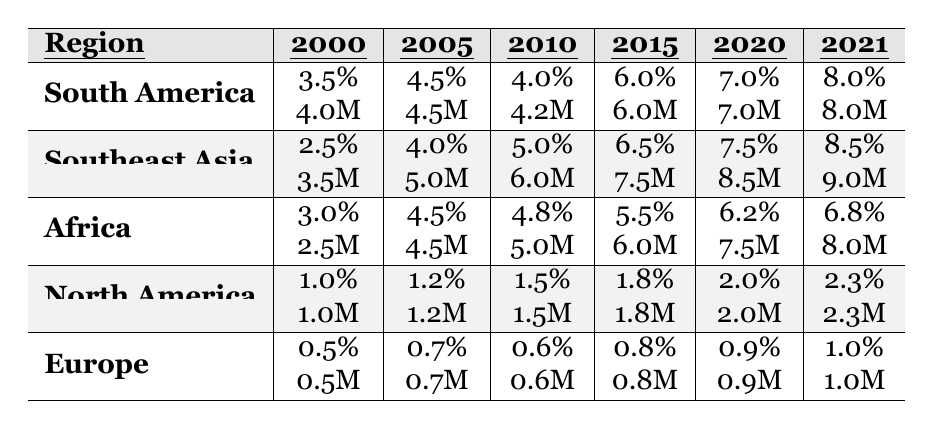What was the deforestation rate in South America in 2010? Looking at the table under the South America row for the year 2010, the deforestation rate is listed as 4.0%.
Answer: 4.0% Which region had the highest deforestation rate in 2021? In the table, reviewing the 2021 column for each region shows that South America had the highest rate at 8.0%.
Answer: South America What is the total deforested area in Southeast Asia from 2000 to 2021? Adding the deforested areas for Southeast Asia from 2000 (3.5M), 2005 (5.0M), 2010 (6.0M), 2015 (7.5M), 2020 (8.5M), and 2021 (9.0M) gives a total of 39.5M hectares.
Answer: 39.5M Has the deforestation rate in Europe ever exceeded 1%? The table shows the deforestation rates for Europe at no point has it exceeded 1%, indicating a 'no' to this question.
Answer: No What was the increase in deforestation rates from 2000 to 2021 for Africa? The deforestation rate for Africa in 2000 is 3.0% and in 2021 is 6.8%. The difference is 6.8% - 3.0% = 3.8%.
Answer: 3.8% Which region showed the most significant increase in deforestation rates between 2015 and 2021? Comparing the rates between 2015 (6.0% for South America, 6.5% for Southeast Asia, 5.5% for Africa, 1.8% for North America, and 0.8% for Europe) reveals that South America increased by 2.0 percentage points (from 6.0% to 8.0%). Southeast Asia also increased by 2.0 percentage points. Africa increased by 1.3 percentage points, North America by 0.5 percentage points, and Europe by 0.2 percentage points. Therefore, South America and Southeast Asia showed the most significant increase.
Answer: South America and Southeast Asia In terms of area deforested in 2020, which region deforested the most area and what was that area? The table indicates that among the regions in 2020, South America deforested 7.0M hectares, which is the highest compared to others.
Answer: South America, 7.0M What is the average deforestation rate for North America across the years 2000 to 2021? The rates for North America are 1.0%, 1.2%, 1.5%, 1.8%, 2.0%, and 2.3%. The average is calculated as (1.0 + 1.2 + 1.5 + 1.8 + 2.0 + 2.3) / 6 = 1.5%.
Answer: 1.5% 